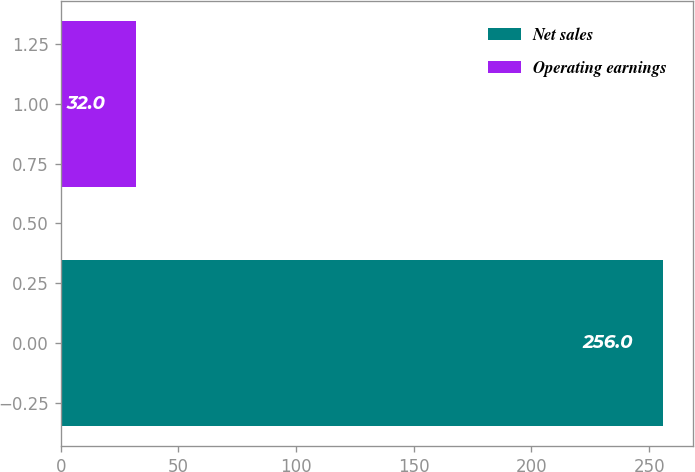Convert chart to OTSL. <chart><loc_0><loc_0><loc_500><loc_500><bar_chart><fcel>Net sales<fcel>Operating earnings<nl><fcel>256<fcel>32<nl></chart> 